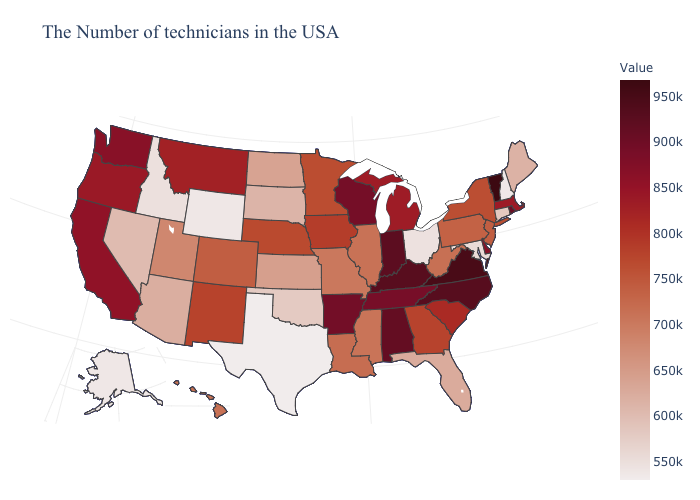Among the states that border Connecticut , does New York have the lowest value?
Give a very brief answer. Yes. Does West Virginia have a higher value than Rhode Island?
Quick response, please. No. Among the states that border South Carolina , which have the highest value?
Concise answer only. North Carolina. Does Alabama have a higher value than Vermont?
Write a very short answer. No. Does Maine have a higher value than Missouri?
Short answer required. No. Is the legend a continuous bar?
Quick response, please. Yes. 